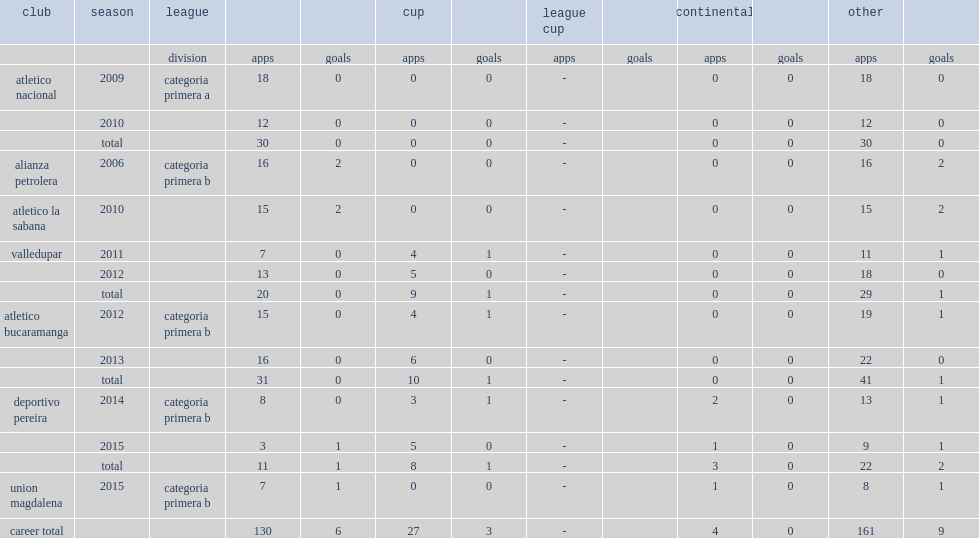Which club did correa play for in 2014? Deportivo pereira. 